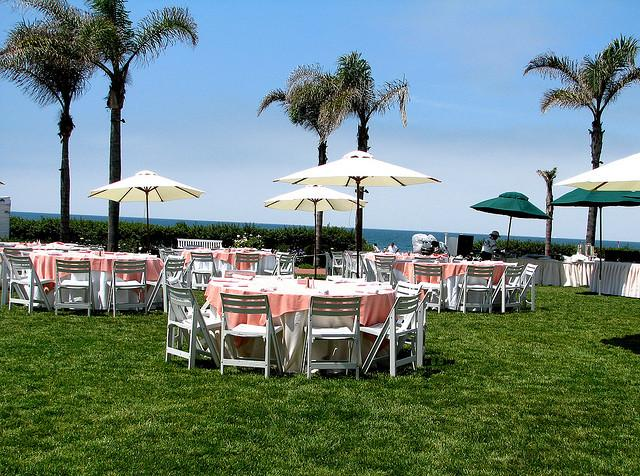What will be happening here in the very near future? Please explain your reasoning. large party. The party will be held here. 